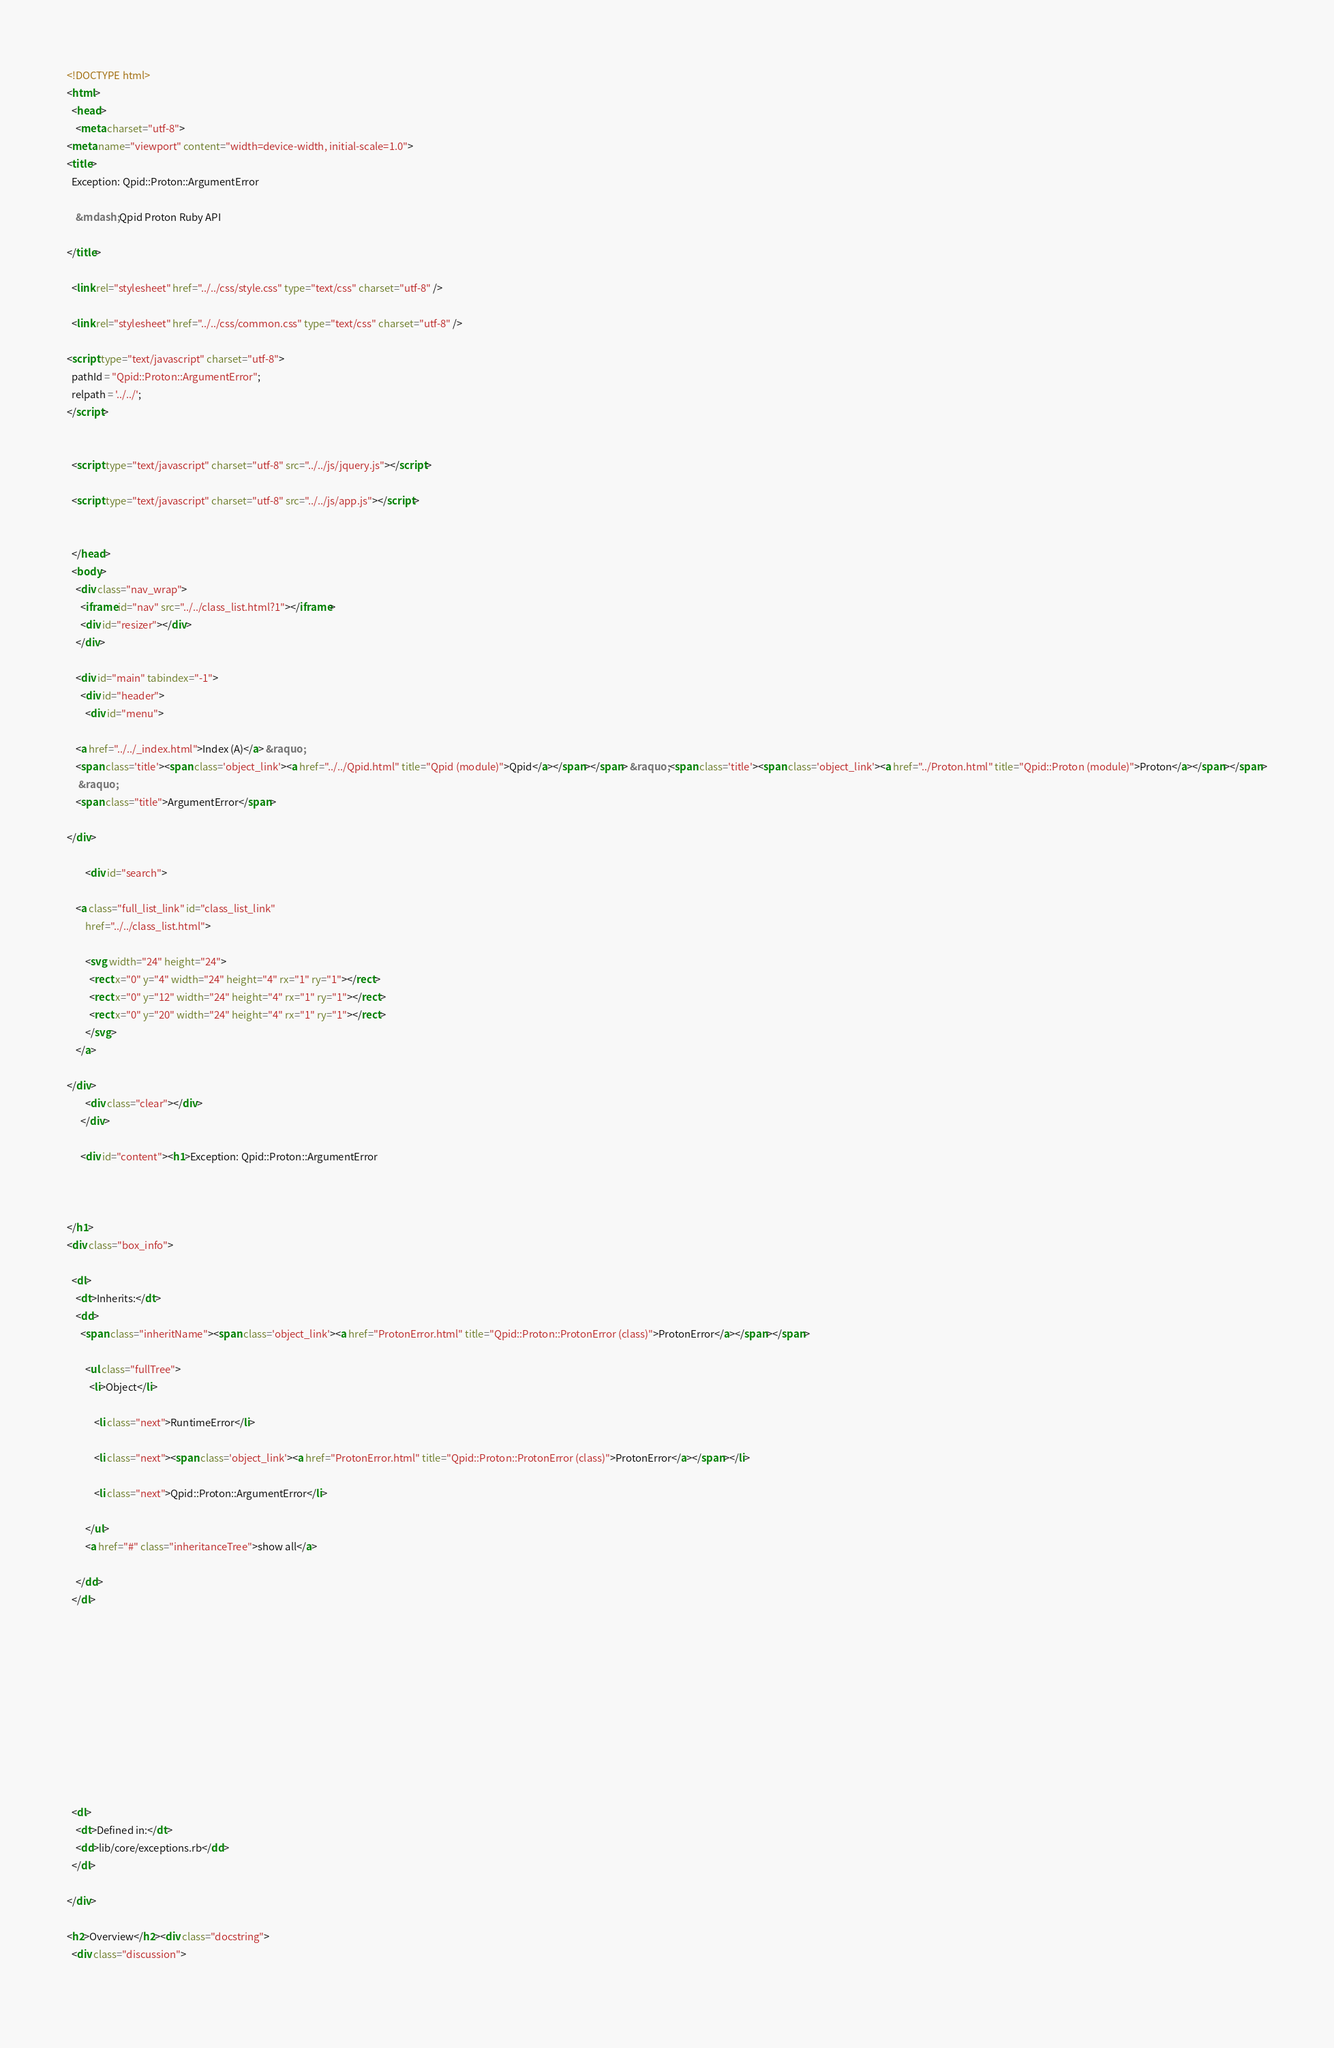<code> <loc_0><loc_0><loc_500><loc_500><_HTML_><!DOCTYPE html>
<html>
  <head>
    <meta charset="utf-8">
<meta name="viewport" content="width=device-width, initial-scale=1.0">
<title>
  Exception: Qpid::Proton::ArgumentError
  
    &mdash; Qpid Proton Ruby API
  
</title>

  <link rel="stylesheet" href="../../css/style.css" type="text/css" charset="utf-8" />

  <link rel="stylesheet" href="../../css/common.css" type="text/css" charset="utf-8" />

<script type="text/javascript" charset="utf-8">
  pathId = "Qpid::Proton::ArgumentError";
  relpath = '../../';
</script>


  <script type="text/javascript" charset="utf-8" src="../../js/jquery.js"></script>

  <script type="text/javascript" charset="utf-8" src="../../js/app.js"></script>


  </head>
  <body>
    <div class="nav_wrap">
      <iframe id="nav" src="../../class_list.html?1"></iframe>
      <div id="resizer"></div>
    </div>

    <div id="main" tabindex="-1">
      <div id="header">
        <div id="menu">
  
    <a href="../../_index.html">Index (A)</a> &raquo;
    <span class='title'><span class='object_link'><a href="../../Qpid.html" title="Qpid (module)">Qpid</a></span></span> &raquo; <span class='title'><span class='object_link'><a href="../Proton.html" title="Qpid::Proton (module)">Proton</a></span></span>
     &raquo; 
    <span class="title">ArgumentError</span>
  
</div>

        <div id="search">
  
    <a class="full_list_link" id="class_list_link"
        href="../../class_list.html">

        <svg width="24" height="24">
          <rect x="0" y="4" width="24" height="4" rx="1" ry="1"></rect>
          <rect x="0" y="12" width="24" height="4" rx="1" ry="1"></rect>
          <rect x="0" y="20" width="24" height="4" rx="1" ry="1"></rect>
        </svg>
    </a>
  
</div>
        <div class="clear"></div>
      </div>

      <div id="content"><h1>Exception: Qpid::Proton::ArgumentError
  
  
  
</h1>
<div class="box_info">
  
  <dl>
    <dt>Inherits:</dt>
    <dd>
      <span class="inheritName"><span class='object_link'><a href="ProtonError.html" title="Qpid::Proton::ProtonError (class)">ProtonError</a></span></span>
      
        <ul class="fullTree">
          <li>Object</li>
          
            <li class="next">RuntimeError</li>
          
            <li class="next"><span class='object_link'><a href="ProtonError.html" title="Qpid::Proton::ProtonError (class)">ProtonError</a></span></li>
          
            <li class="next">Qpid::Proton::ArgumentError</li>
          
        </ul>
        <a href="#" class="inheritanceTree">show all</a>
      
    </dd>
  </dl>
  

  
  
  
  
  

  

  
  <dl>
    <dt>Defined in:</dt>
    <dd>lib/core/exceptions.rb</dd>
  </dl>
  
</div>

<h2>Overview</h2><div class="docstring">
  <div class="discussion">
    </code> 